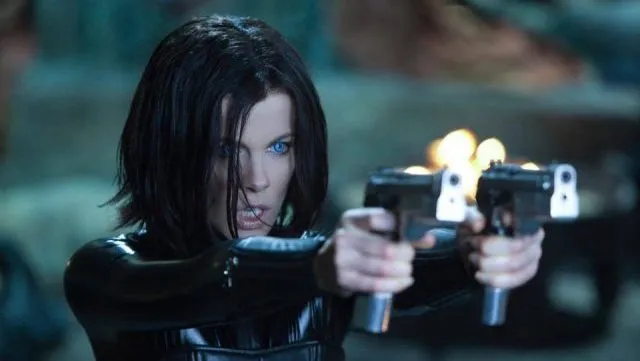Describe the most striking visual elements you observe. The most striking visual elements in the image are Selene's piercing blue eyes and the two pistols she holds. Her eyes stand out sharply against the dark background, conveying determination and intensity. The dual pistols, held confidently, imply readiness for combat and add to the overall dynamic feel of the image. The dark leather outfit and short bob hairstyle further enhance her formidable warrior persona. How do these elements contribute to the character's overall image? These elements collectively build an image of a powerful, no-nonsense warrior. The piercing blue eyes are mesmerizing and signal alertness and focus, while the pistols indicate that she is armed and ready for any threat. Her outfit is both practical and stylish, suggesting agility and readiness. The combination of her intense gaze, weaponry, and sleek attire creates a portrayal of a character who is both captivating and intimidating. What do you think she's preparing for in this scene? She appears to be preparing for an imminent confrontation or battle. Her focused expression and the direction of her guns suggest she is ready to engage a threat. The tense atmosphere implies that she is either defending herself from an approaching danger or planning a proactive strike against an adversary. This readiness is a clear indicator of her experience and resilience in combat situations. Imagine a scenario where she finds herself fighting in an underwater world. How would her strategies and attire need to change? In an underwater world, Selene's strategies and attire would need significant adaptation. Her black leather outfit might be replaced with a form-fitting, flexible wetsuit that still retains her dark, sleek aesthetic but provides better mobility and protection underwater. Her pistols would likely be swapped for weapons suited to underwater use, such as a spear gun or a specially designed undersea firearm. Tactics like stealth and quick, efficient movements would become crucial as sound travels differently under water, necessitating a more calculated approach to avoid detection and outmaneuver adversaries. Navigating underwater currents and using the terrain to her advantage would be new skills she'd master, showcasing her adaptability in any environment. Based on her look and gear, create a realistic short scene of her in action. Selene moved silently through the dark alley, her eyes scanning every shadow for signs of the enemy. The air was thick with tension, and she could sense the impending danger. Suddenly, a figure darted out from behind a dumpster, gun aimed directly at her. Without hesitation, Selene dropped to one knee, her twin pistols barking fire. The assailant crumpled to the ground, and Selene was already moving, her form a blur of lethal precision. She slid behind cover, reloading swiftly, her senses on high alert. Another enemy appeared at the end of the alley, and she rolled out, firing with deadly accuracy. The night was hers, and no threat would escape her relentless pursuit. 